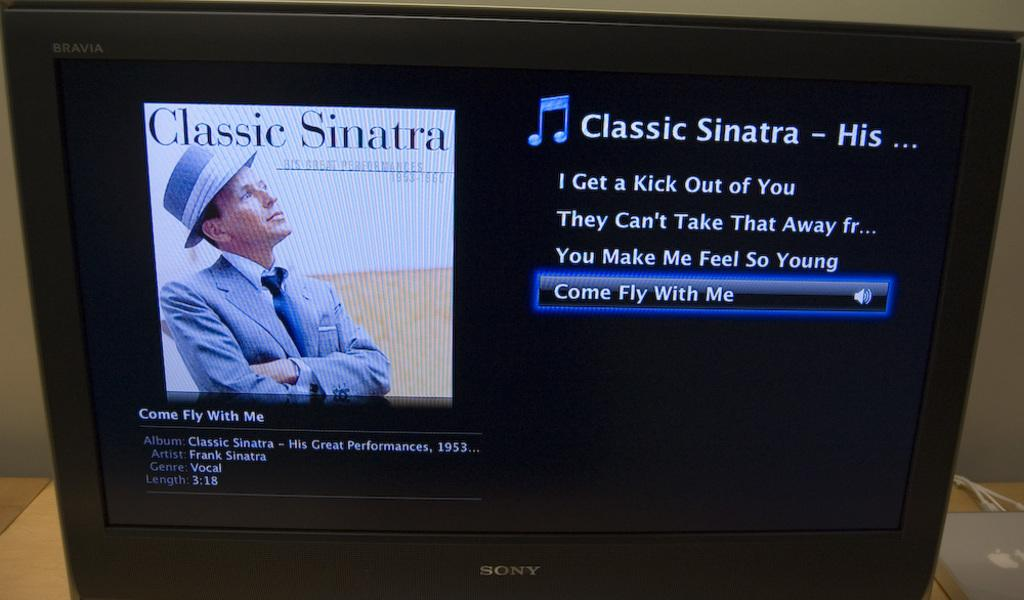Provide a one-sentence caption for the provided image. an album that has the words classic sinatra on it. 